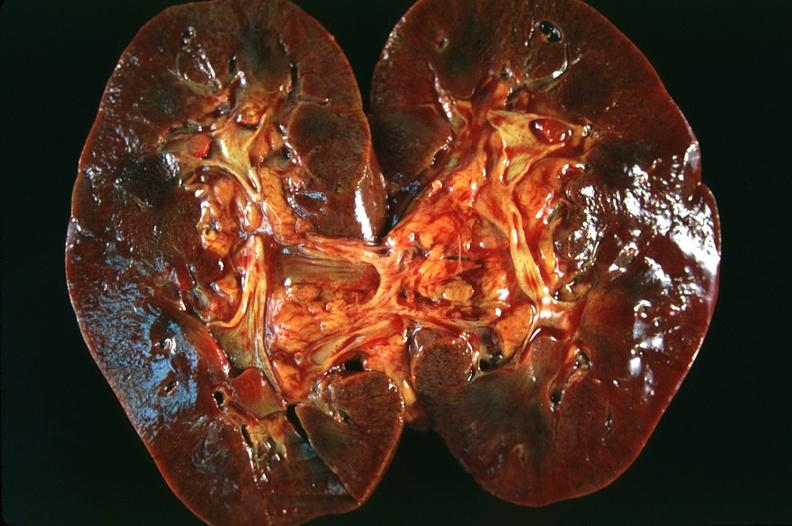where is this?
Answer the question using a single word or phrase. Urinary 